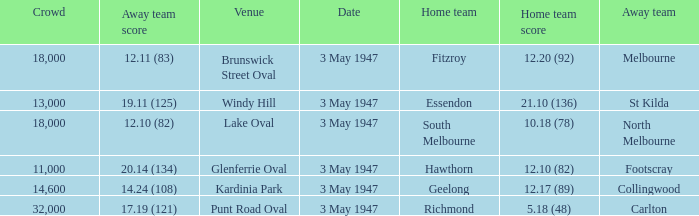I'm looking to parse the entire table for insights. Could you assist me with that? {'header': ['Crowd', 'Away team score', 'Venue', 'Date', 'Home team', 'Home team score', 'Away team'], 'rows': [['18,000', '12.11 (83)', 'Brunswick Street Oval', '3 May 1947', 'Fitzroy', '12.20 (92)', 'Melbourne'], ['13,000', '19.11 (125)', 'Windy Hill', '3 May 1947', 'Essendon', '21.10 (136)', 'St Kilda'], ['18,000', '12.10 (82)', 'Lake Oval', '3 May 1947', 'South Melbourne', '10.18 (78)', 'North Melbourne'], ['11,000', '20.14 (134)', 'Glenferrie Oval', '3 May 1947', 'Hawthorn', '12.10 (82)', 'Footscray'], ['14,600', '14.24 (108)', 'Kardinia Park', '3 May 1947', 'Geelong', '12.17 (89)', 'Collingwood'], ['32,000', '17.19 (121)', 'Punt Road Oval', '3 May 1947', 'Richmond', '5.18 (48)', 'Carlton']]} Which venue did the away team score 12.10 (82)? Lake Oval. 